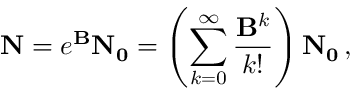<formula> <loc_0><loc_0><loc_500><loc_500>N = e ^ { B } N _ { 0 } = \left ( \sum _ { k = 0 } ^ { \infty } \frac { B ^ { k } } { k ! } \right ) N _ { 0 } \, ,</formula> 